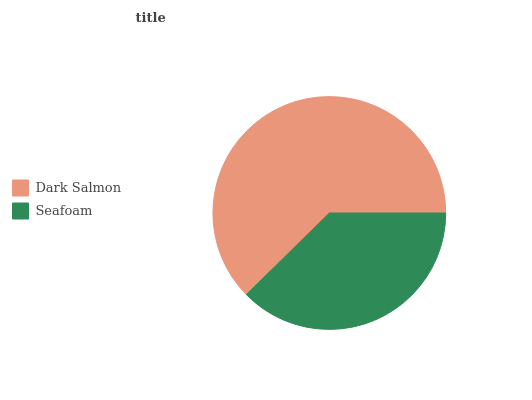Is Seafoam the minimum?
Answer yes or no. Yes. Is Dark Salmon the maximum?
Answer yes or no. Yes. Is Seafoam the maximum?
Answer yes or no. No. Is Dark Salmon greater than Seafoam?
Answer yes or no. Yes. Is Seafoam less than Dark Salmon?
Answer yes or no. Yes. Is Seafoam greater than Dark Salmon?
Answer yes or no. No. Is Dark Salmon less than Seafoam?
Answer yes or no. No. Is Dark Salmon the high median?
Answer yes or no. Yes. Is Seafoam the low median?
Answer yes or no. Yes. Is Seafoam the high median?
Answer yes or no. No. Is Dark Salmon the low median?
Answer yes or no. No. 